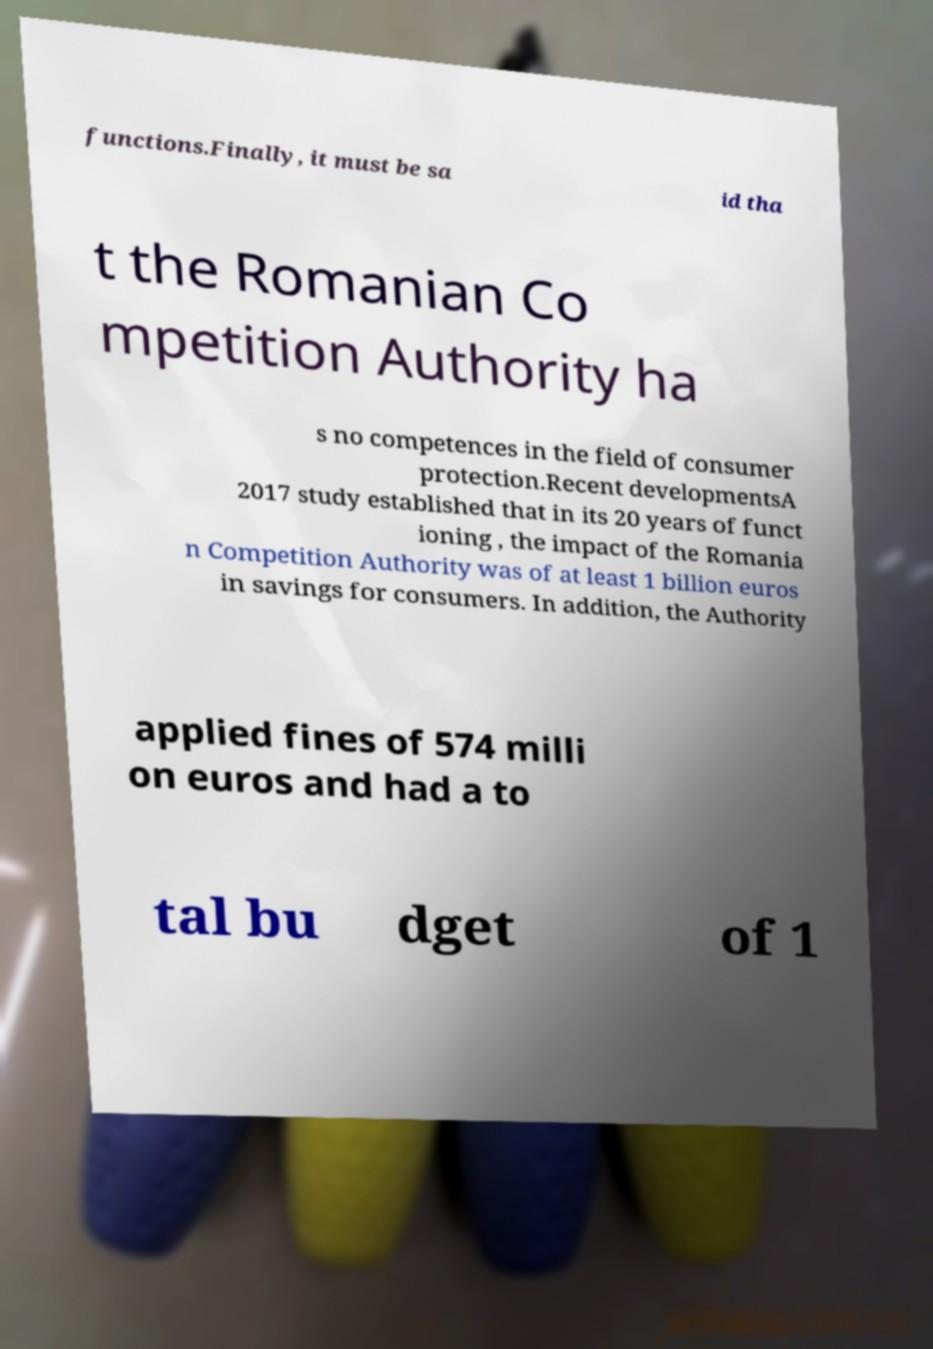Please identify and transcribe the text found in this image. functions.Finally, it must be sa id tha t the Romanian Co mpetition Authority ha s no competences in the field of consumer protection.Recent developmentsA 2017 study established that in its 20 years of funct ioning , the impact of the Romania n Competition Authority was of at least 1 billion euros in savings for consumers. In addition, the Authority applied fines of 574 milli on euros and had a to tal bu dget of 1 